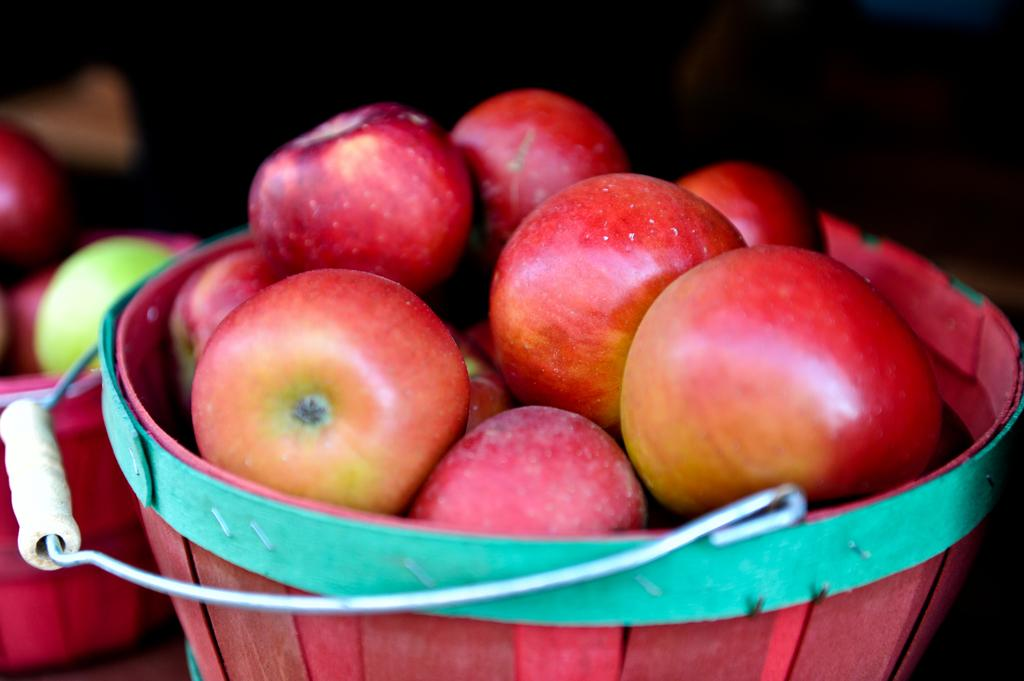What objects are present in the image? There are baskets in the image. What are the baskets filled with? The baskets contain apples. Reasoning: Let's think step by step by step in order to produce the conversation. We start by identifying the main objects in the image, which are the baskets. Then, we describe what is inside the baskets, which are apples. Each question is designed to elicit a specific detail about the image that is known from the provided facts. Absurd Question/Answer: Is there steam coming out of the baskets in the image? No, there is no steam present in the image. What is the title of the book that is lying on the baskets in the image? There is no book present in the image, so there is no title to mention. 